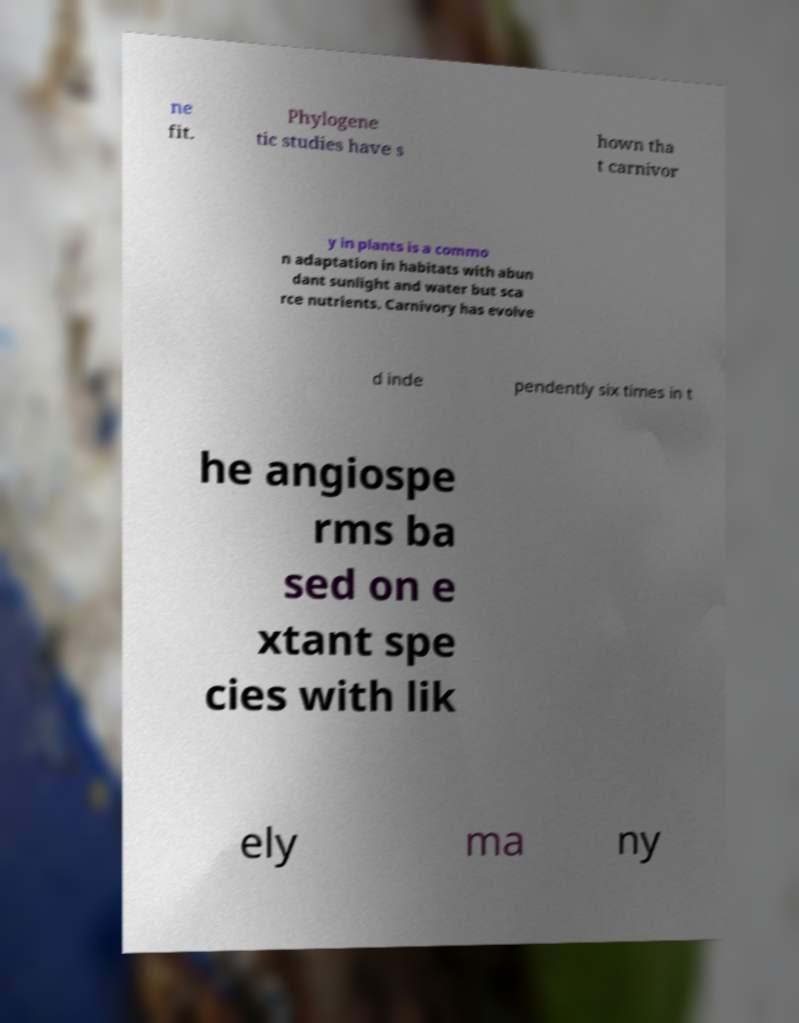Please read and relay the text visible in this image. What does it say? ne fit. Phylogene tic studies have s hown tha t carnivor y in plants is a commo n adaptation in habitats with abun dant sunlight and water but sca rce nutrients. Carnivory has evolve d inde pendently six times in t he angiospe rms ba sed on e xtant spe cies with lik ely ma ny 